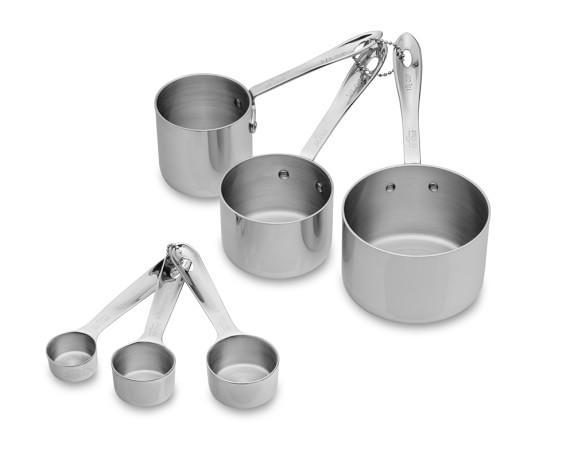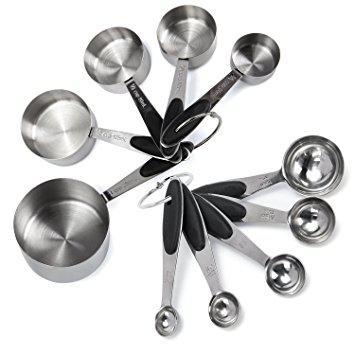The first image is the image on the left, the second image is the image on the right. For the images shown, is this caption "Exactly two sets of measuring cups and spoons are fanned for display." true? Answer yes or no. Yes. 